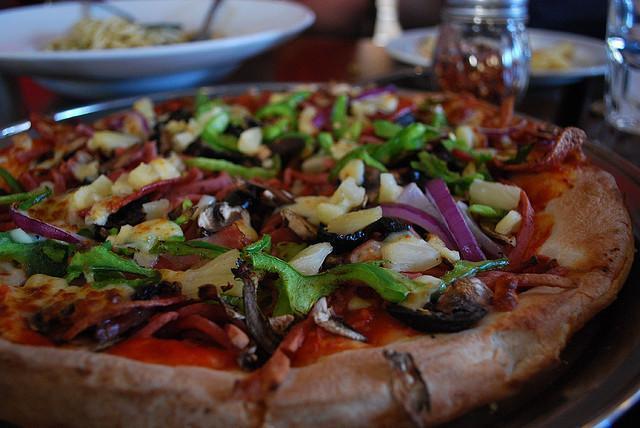How many cups can be seen?
Give a very brief answer. 2. How many white remotes do you see?
Give a very brief answer. 0. 